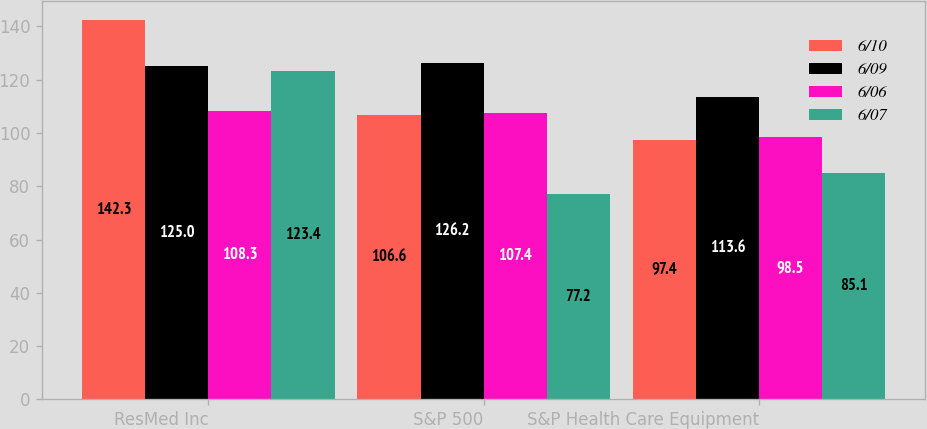Convert chart. <chart><loc_0><loc_0><loc_500><loc_500><stacked_bar_chart><ecel><fcel>ResMed Inc<fcel>S&P 500<fcel>S&P Health Care Equipment<nl><fcel>6/10<fcel>142.3<fcel>106.6<fcel>97.4<nl><fcel>6/09<fcel>125<fcel>126.2<fcel>113.6<nl><fcel>6/06<fcel>108.3<fcel>107.4<fcel>98.5<nl><fcel>6/07<fcel>123.4<fcel>77.2<fcel>85.1<nl></chart> 